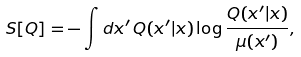<formula> <loc_0><loc_0><loc_500><loc_500>S [ Q ] = - \int d x ^ { \prime } \, Q ( x ^ { \prime } | x ) \log \frac { Q ( x ^ { \prime } | x ) } { \mu ( x ^ { \prime } ) } ,</formula> 